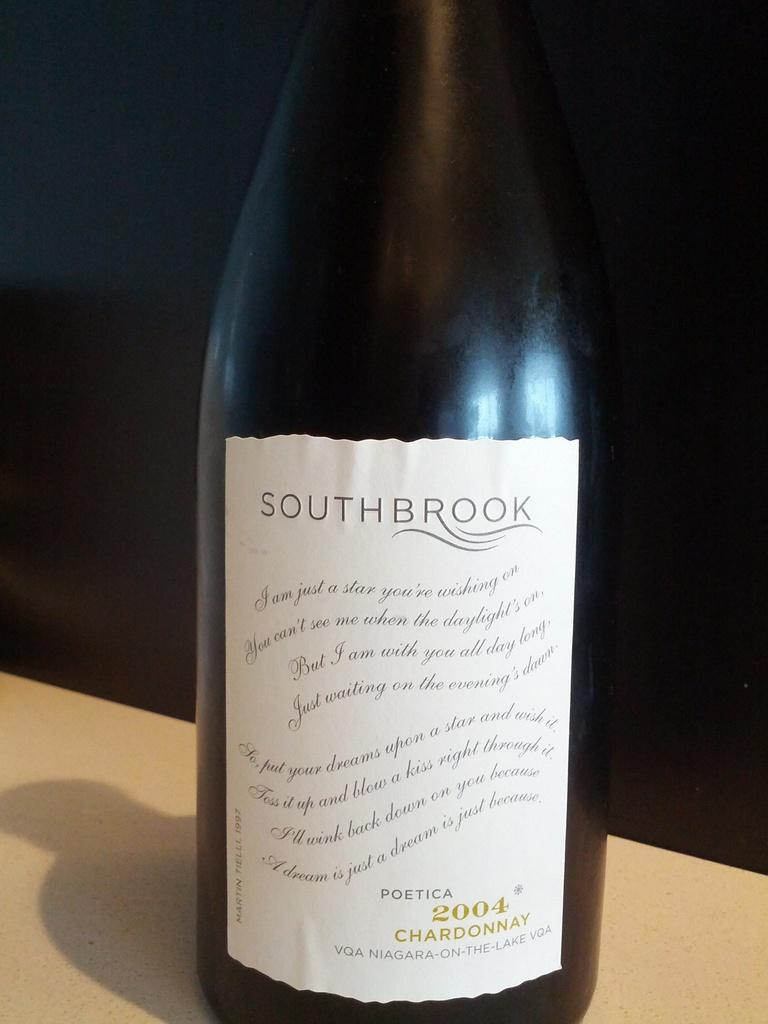<image>
Create a compact narrative representing the image presented. A bottle of Southbrook chardonnay is from the year 2004. 